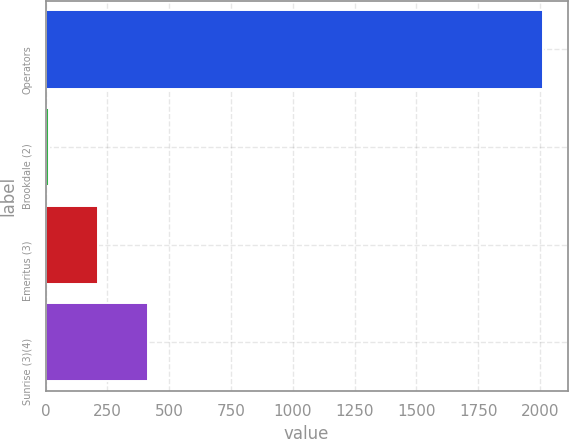Convert chart to OTSL. <chart><loc_0><loc_0><loc_500><loc_500><bar_chart><fcel>Operators<fcel>Brookdale (2)<fcel>Emeritus (3)<fcel>Sunrise (3)(4)<nl><fcel>2011<fcel>14<fcel>213.7<fcel>413.4<nl></chart> 